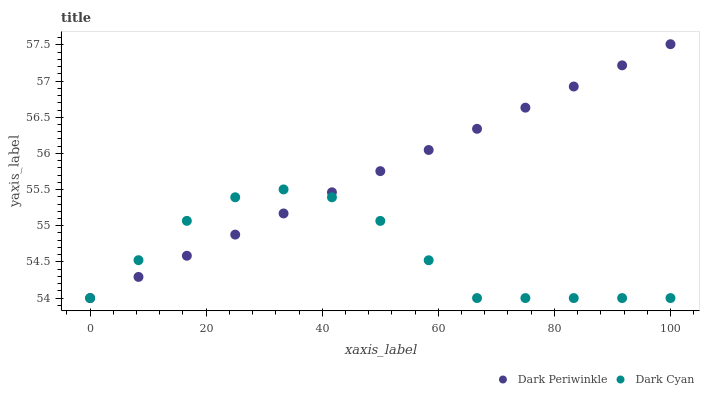Does Dark Cyan have the minimum area under the curve?
Answer yes or no. Yes. Does Dark Periwinkle have the maximum area under the curve?
Answer yes or no. Yes. Does Dark Periwinkle have the minimum area under the curve?
Answer yes or no. No. Is Dark Periwinkle the smoothest?
Answer yes or no. Yes. Is Dark Cyan the roughest?
Answer yes or no. Yes. Is Dark Periwinkle the roughest?
Answer yes or no. No. Does Dark Cyan have the lowest value?
Answer yes or no. Yes. Does Dark Periwinkle have the highest value?
Answer yes or no. Yes. Does Dark Periwinkle intersect Dark Cyan?
Answer yes or no. Yes. Is Dark Periwinkle less than Dark Cyan?
Answer yes or no. No. Is Dark Periwinkle greater than Dark Cyan?
Answer yes or no. No. 